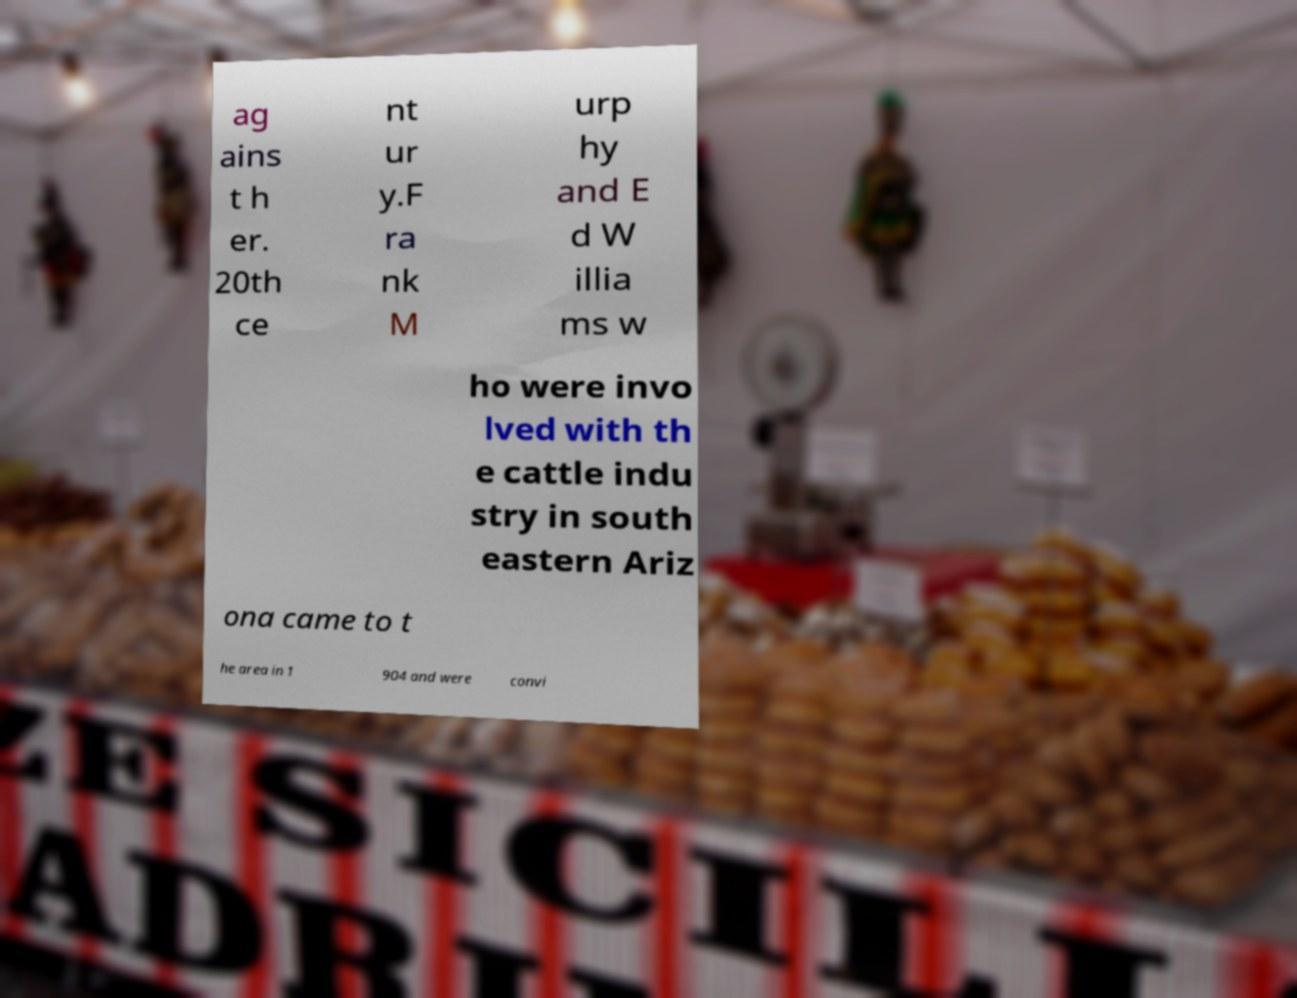What messages or text are displayed in this image? I need them in a readable, typed format. ag ains t h er. 20th ce nt ur y.F ra nk M urp hy and E d W illia ms w ho were invo lved with th e cattle indu stry in south eastern Ariz ona came to t he area in 1 904 and were convi 